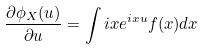<formula> <loc_0><loc_0><loc_500><loc_500>\frac { \partial \phi _ { X } ( u ) } { \partial u } & = \int i x e ^ { i x u } f ( x ) d x</formula> 